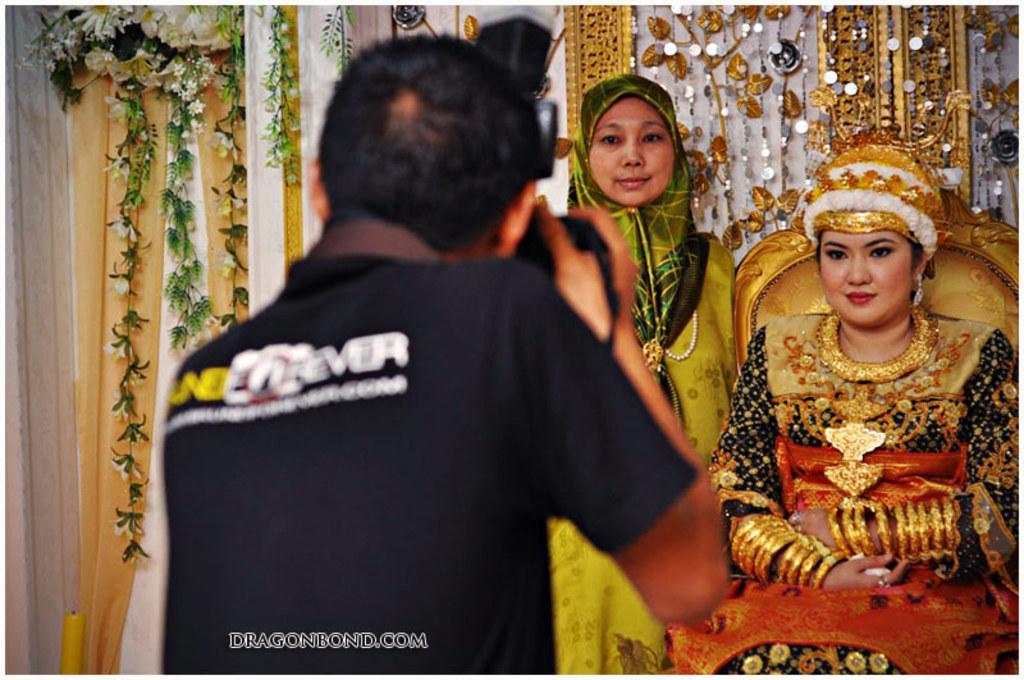How would you summarize this image in a sentence or two? In this image there is a photographer clicking pictures of a woman sitting in a chair, beside the woman there is another woman standing, behind them there are flowers decorated on a curtain, at the bottom of the image there is some text. 